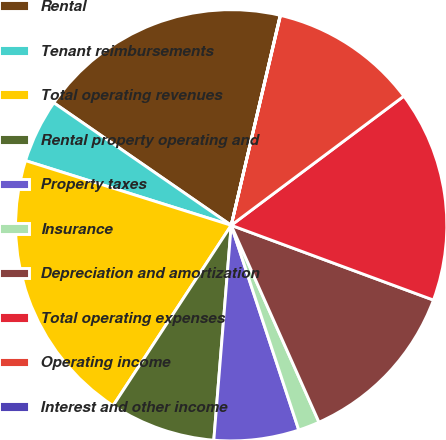<chart> <loc_0><loc_0><loc_500><loc_500><pie_chart><fcel>Rental<fcel>Tenant reimbursements<fcel>Total operating revenues<fcel>Rental property operating and<fcel>Property taxes<fcel>Insurance<fcel>Depreciation and amortization<fcel>Total operating expenses<fcel>Operating income<fcel>Interest and other income<nl><fcel>19.03%<fcel>4.77%<fcel>20.62%<fcel>7.94%<fcel>6.36%<fcel>1.6%<fcel>12.69%<fcel>15.86%<fcel>11.11%<fcel>0.02%<nl></chart> 